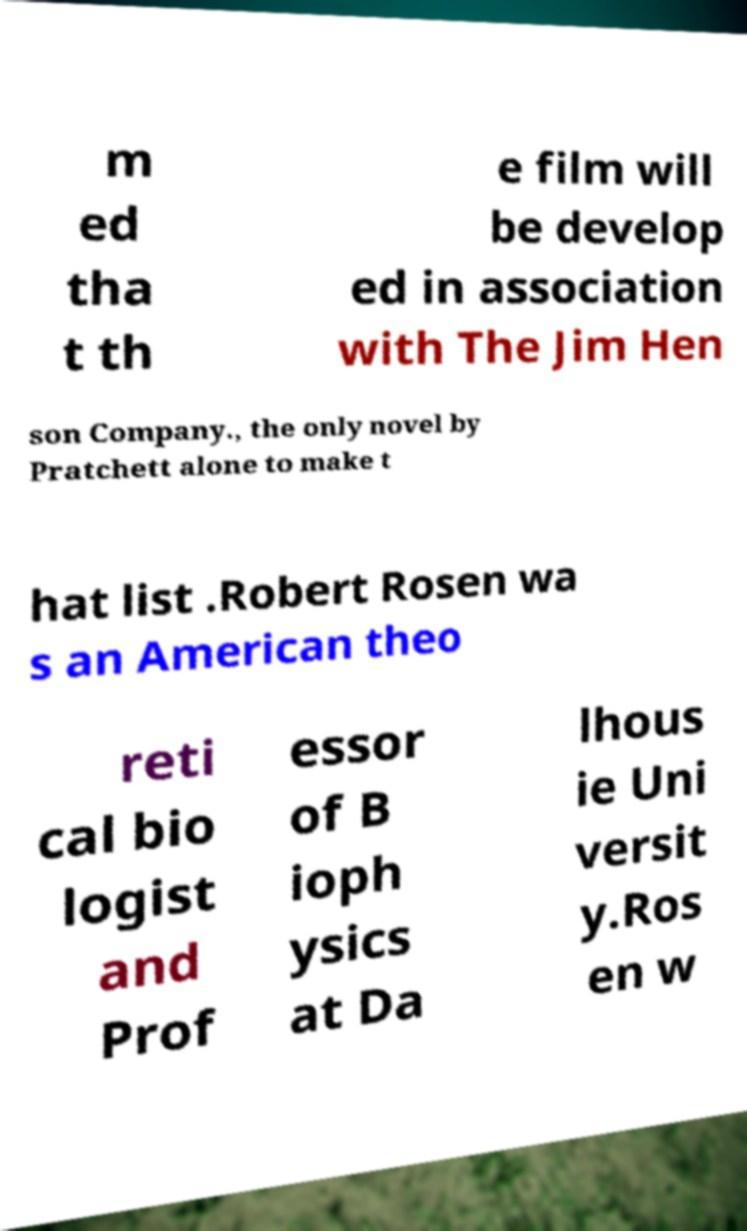Could you extract and type out the text from this image? m ed tha t th e film will be develop ed in association with The Jim Hen son Company., the only novel by Pratchett alone to make t hat list .Robert Rosen wa s an American theo reti cal bio logist and Prof essor of B ioph ysics at Da lhous ie Uni versit y.Ros en w 